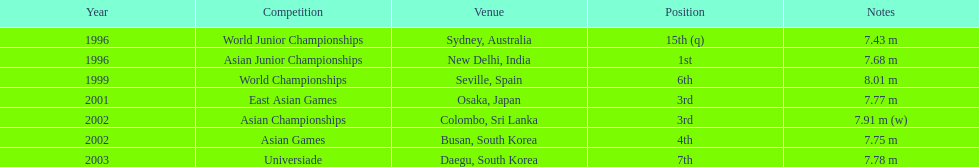70 m? 5. 